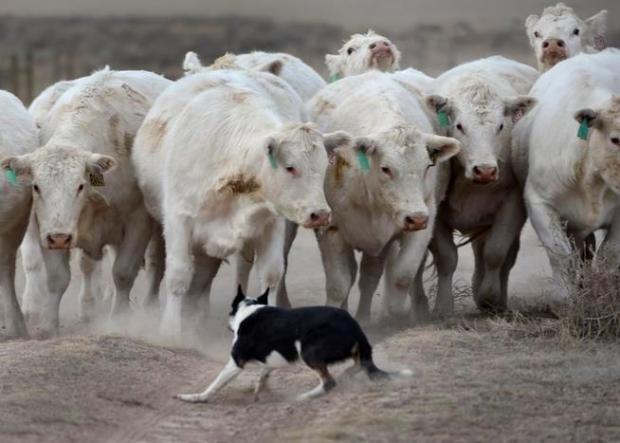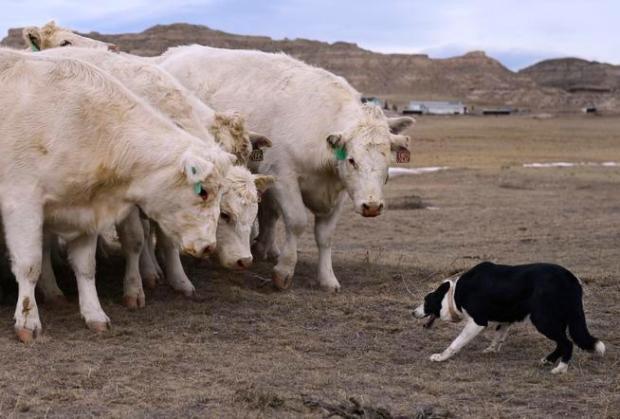The first image is the image on the left, the second image is the image on the right. Examine the images to the left and right. Is the description "Left and right images each show a black-and-white dog in front of multiple standing cattle." accurate? Answer yes or no. Yes. The first image is the image on the left, the second image is the image on the right. For the images shown, is this caption "One image contains a sheep dog herding three or more sheep." true? Answer yes or no. No. 